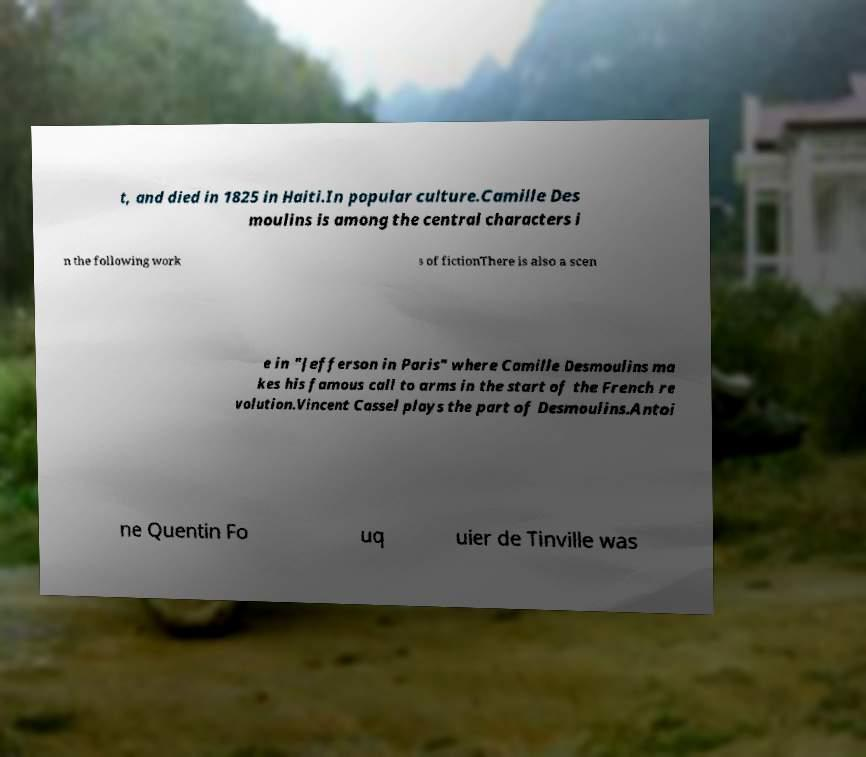Please read and relay the text visible in this image. What does it say? t, and died in 1825 in Haiti.In popular culture.Camille Des moulins is among the central characters i n the following work s of fictionThere is also a scen e in "Jefferson in Paris" where Camille Desmoulins ma kes his famous call to arms in the start of the French re volution.Vincent Cassel plays the part of Desmoulins.Antoi ne Quentin Fo uq uier de Tinville was 